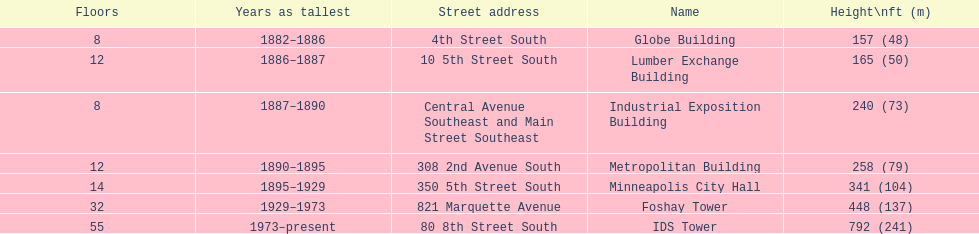How many buildings on the list are taller than 200 feet? 5. 